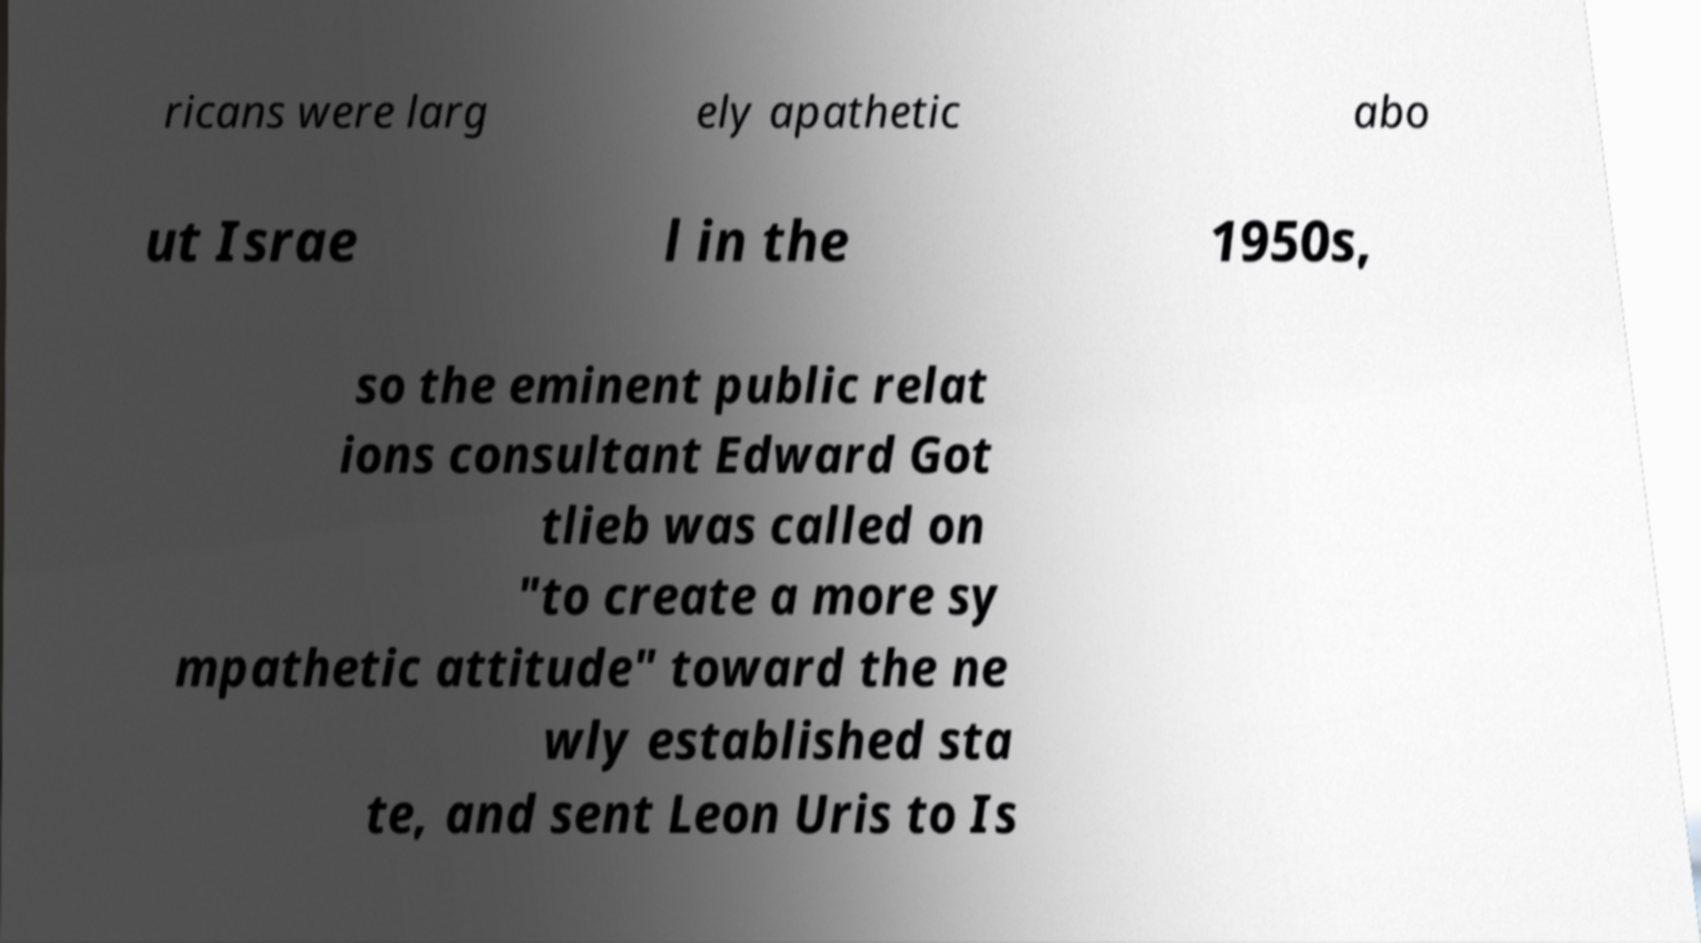There's text embedded in this image that I need extracted. Can you transcribe it verbatim? ricans were larg ely apathetic abo ut Israe l in the 1950s, so the eminent public relat ions consultant Edward Got tlieb was called on "to create a more sy mpathetic attitude" toward the ne wly established sta te, and sent Leon Uris to Is 